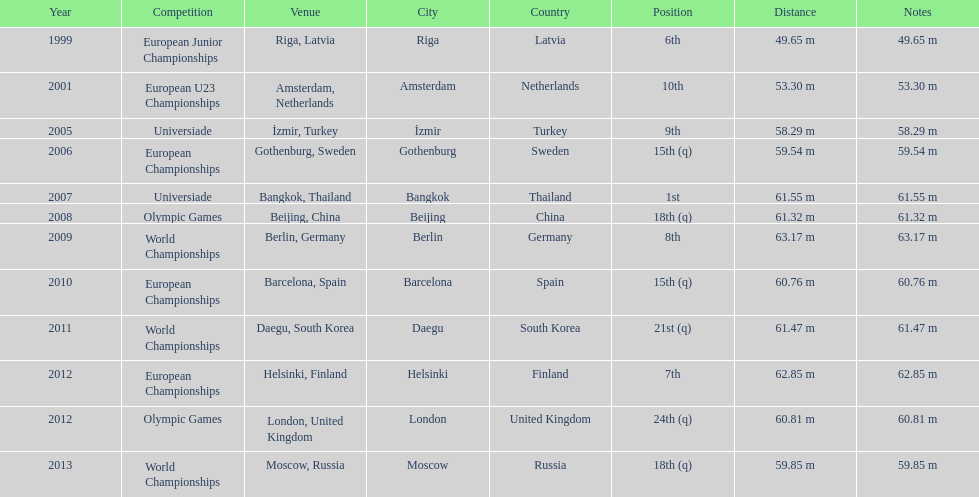What are the years listed prior to 2007? 1999, 2001, 2005, 2006. What are their corresponding finishes? 6th, 10th, 9th, 15th (q). Which is the highest? 6th. 